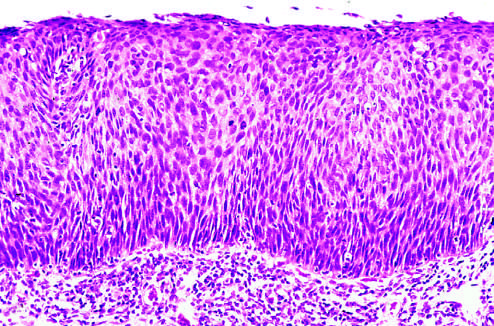does the low-power view show that the entire thickness of the epithelium is replaced by atypical dysplastic cells?
Answer the question using a single word or phrase. Yes 